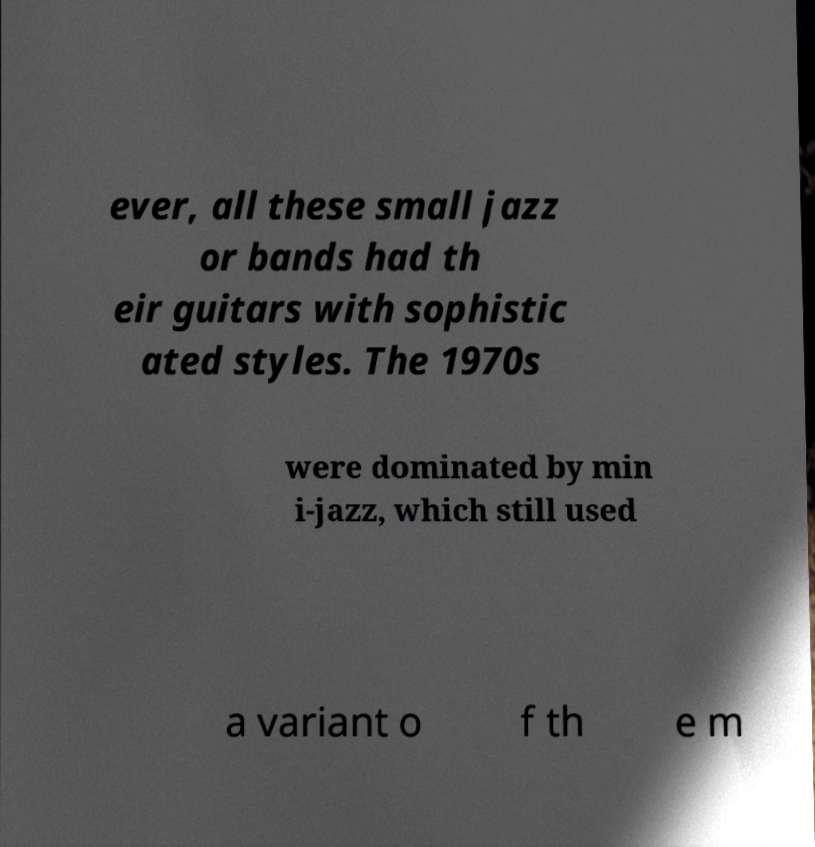Can you read and provide the text displayed in the image?This photo seems to have some interesting text. Can you extract and type it out for me? ever, all these small jazz or bands had th eir guitars with sophistic ated styles. The 1970s were dominated by min i-jazz, which still used a variant o f th e m 